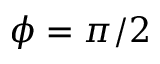<formula> <loc_0><loc_0><loc_500><loc_500>\phi = \pi / 2</formula> 